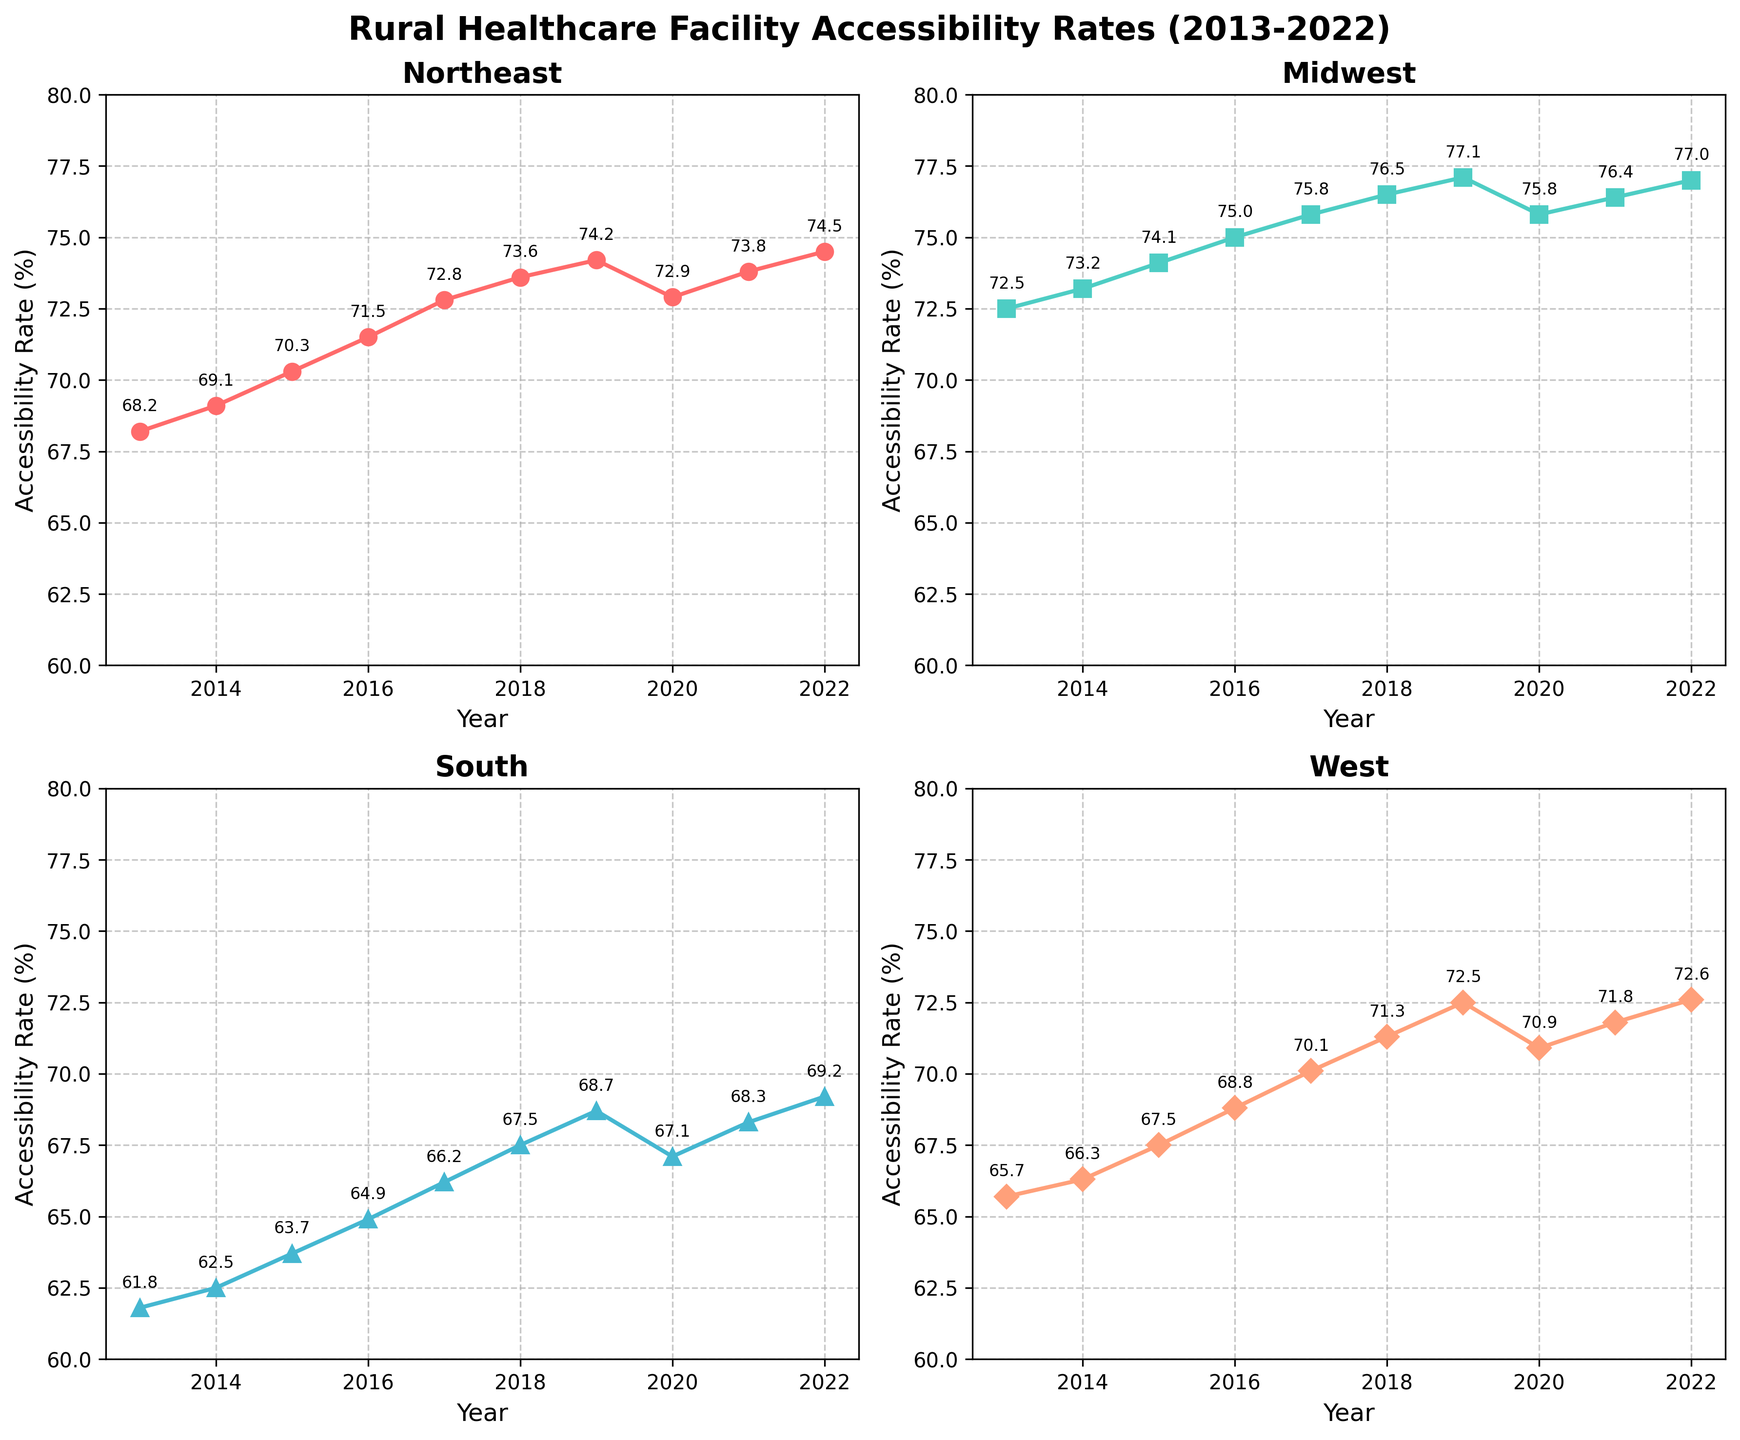Which region had the highest accessibility rate in 2019? In 2019, the data shows the following accessibility rates: Northeast (74.2), Midwest (77.1), South (68.7), and West (72.5). The Midwest has the highest rate.
Answer: Midwest Which year had the lowest accessibility rate for the Northeast region? Reviewing the plotted data for the Northeast region, the lowest accessibility rate occurs in 2013 with a rate of 68.2.
Answer: 2013 What is the change in accessibility rate for the West region from 2013 to 2022? The West region's accessibility rate was 65.7 in 2013 and 72.6 in 2022. The change is 72.6 - 65.7 = 6.9 percentage points.
Answer: 6.9 Compare the accessibility rates of the South and Midwest regions in 2020. Which is higher and by how much? The rates in 2020 are South (67.1) and Midwest (75.8). The Midwest rate is higher by 75.8 - 67.1 = 8.7 percentage points.
Answer: Midwest, 8.7 Which region shows the most consistent increase in accessibility rates over the decade? By examining the trends visually, all regions show an increase, but the Midwest has a more consistent and steady increase without any major drops over the years.
Answer: Midwest In which year did the South region's accessibility rate surpass 65%? The South's rates are below 65% until 2015 when it reaches 65.7%, so this is the first year it surpasses 65%.
Answer: 2015 What was the average accessibility rate for the Midwest region over the decade? The Midwest's rates are: 72.5, 73.2, 74.1, 75.0, 75.8, 76.5, 77.1, 75.8, 76.4, and 77.0. Their average is (72.5 + 73.2 + 74.1 + 75.0 + 75.8 + 76.5 + 77.1 + 75.8 + 76.4 + 77.0) / 10 = 75.34.
Answer: 75.34 Did any region experience a decline in accessibility rates between any consecutive years? If so, which region and what were the rates before and after the decline? The Northeast and South both show declines between 2019 to 2020. The Northeast drops from 74.2 to 72.9, and the South drops from 68.7 to 67.1.
Answer: Northeast: 74.2 to 72.9, South: 68.7 to 67.1 